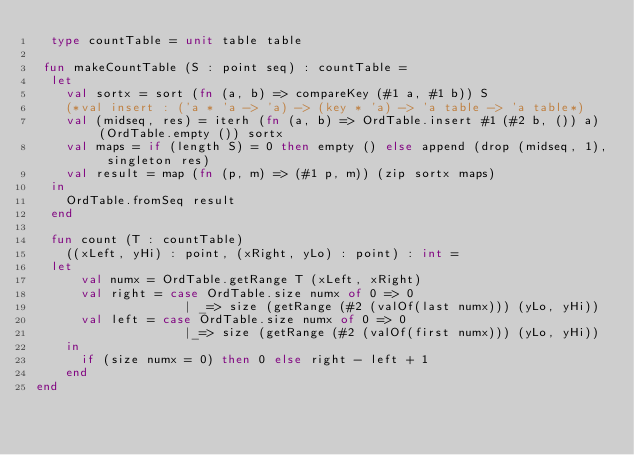Convert code to text. <code><loc_0><loc_0><loc_500><loc_500><_SML_>  type countTable = unit table table

 fun makeCountTable (S : point seq) : countTable = 
  let
    val sortx = sort (fn (a, b) => compareKey (#1 a, #1 b)) S
    (*val insert : ('a * 'a -> 'a) -> (key * 'a) -> 'a table -> 'a table*)
    val (midseq, res) = iterh (fn (a, b) => OrdTable.insert #1 (#2 b, ()) a) (OrdTable.empty ()) sortx
    val maps = if (length S) = 0 then empty () else append (drop (midseq, 1), singleton res)
    val result = map (fn (p, m) => (#1 p, m)) (zip sortx maps)
  in
    OrdTable.fromSeq result
  end

  fun count (T : countTable)
    ((xLeft, yHi) : point, (xRight, yLo) : point) : int =
  let
      val numx = OrdTable.getRange T (xLeft, xRight)
      val right = case OrdTable.size numx of 0 => 0 
                    | _=> size (getRange (#2 (valOf(last numx))) (yLo, yHi))
      val left = case OrdTable.size numx of 0 => 0 
                    |_=> size (getRange (#2 (valOf(first numx))) (yLo, yHi))
    in
      if (size numx = 0) then 0 else right - left + 1
    end
end
</code> 